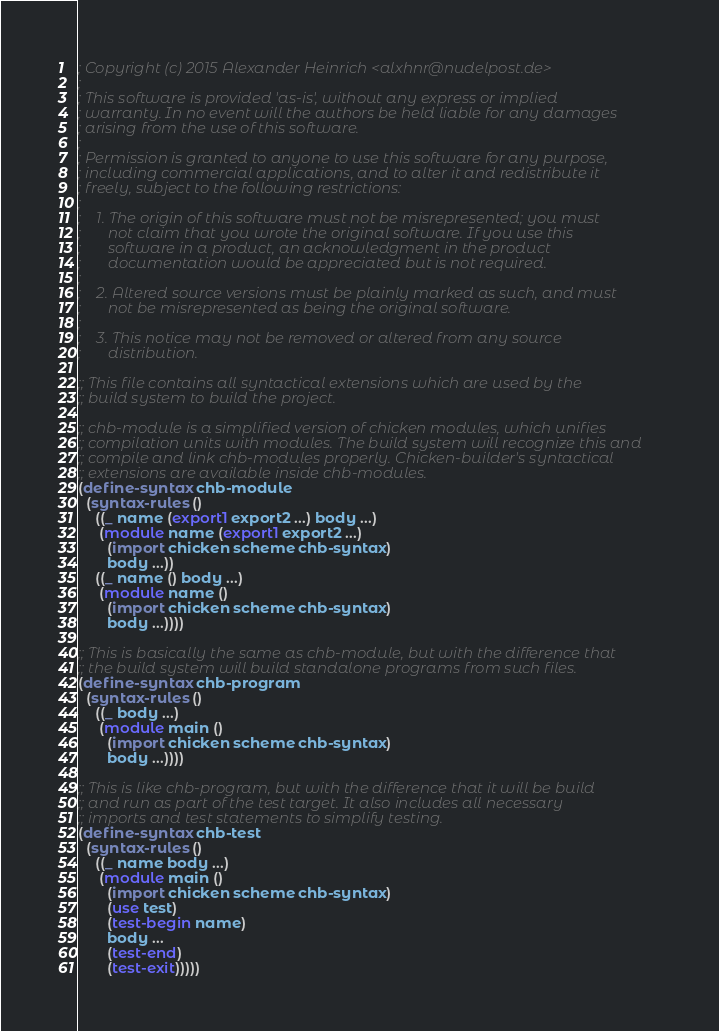<code> <loc_0><loc_0><loc_500><loc_500><_Scheme_>; Copyright (c) 2015 Alexander Heinrich <alxhnr@nudelpost.de>
;
; This software is provided 'as-is', without any express or implied
; warranty. In no event will the authors be held liable for any damages
; arising from the use of this software.
;
; Permission is granted to anyone to use this software for any purpose,
; including commercial applications, and to alter it and redistribute it
; freely, subject to the following restrictions:
;
;    1. The origin of this software must not be misrepresented; you must
;       not claim that you wrote the original software. If you use this
;       software in a product, an acknowledgment in the product
;       documentation would be appreciated but is not required.
;
;    2. Altered source versions must be plainly marked as such, and must
;       not be misrepresented as being the original software.
;
;    3. This notice may not be removed or altered from any source
;       distribution.

;; This file contains all syntactical extensions which are used by the
;; build system to build the project.

;; chb-module is a simplified version of chicken modules, which unifies
;; compilation units with modules. The build system will recognize this and
;; compile and link chb-modules properly. Chicken-builder's syntactical
;; extensions are available inside chb-modules.
(define-syntax chb-module
  (syntax-rules ()
    ((_ name (export1 export2 ...) body ...)
     (module name (export1 export2 ...)
       (import chicken scheme chb-syntax)
       body ...))
    ((_ name () body ...)
     (module name ()
       (import chicken scheme chb-syntax)
       body ...))))

;; This is basically the same as chb-module, but with the difference that
;; the build system will build standalone programs from such files.
(define-syntax chb-program
  (syntax-rules ()
    ((_ body ...)
     (module main ()
       (import chicken scheme chb-syntax)
       body ...))))

;; This is like chb-program, but with the difference that it will be build
;; and run as part of the test target. It also includes all necessary
;; imports and test statements to simplify testing.
(define-syntax chb-test
  (syntax-rules ()
    ((_ name body ...)
     (module main ()
       (import chicken scheme chb-syntax)
       (use test)
       (test-begin name)
       body ...
       (test-end)
       (test-exit)))))
</code> 